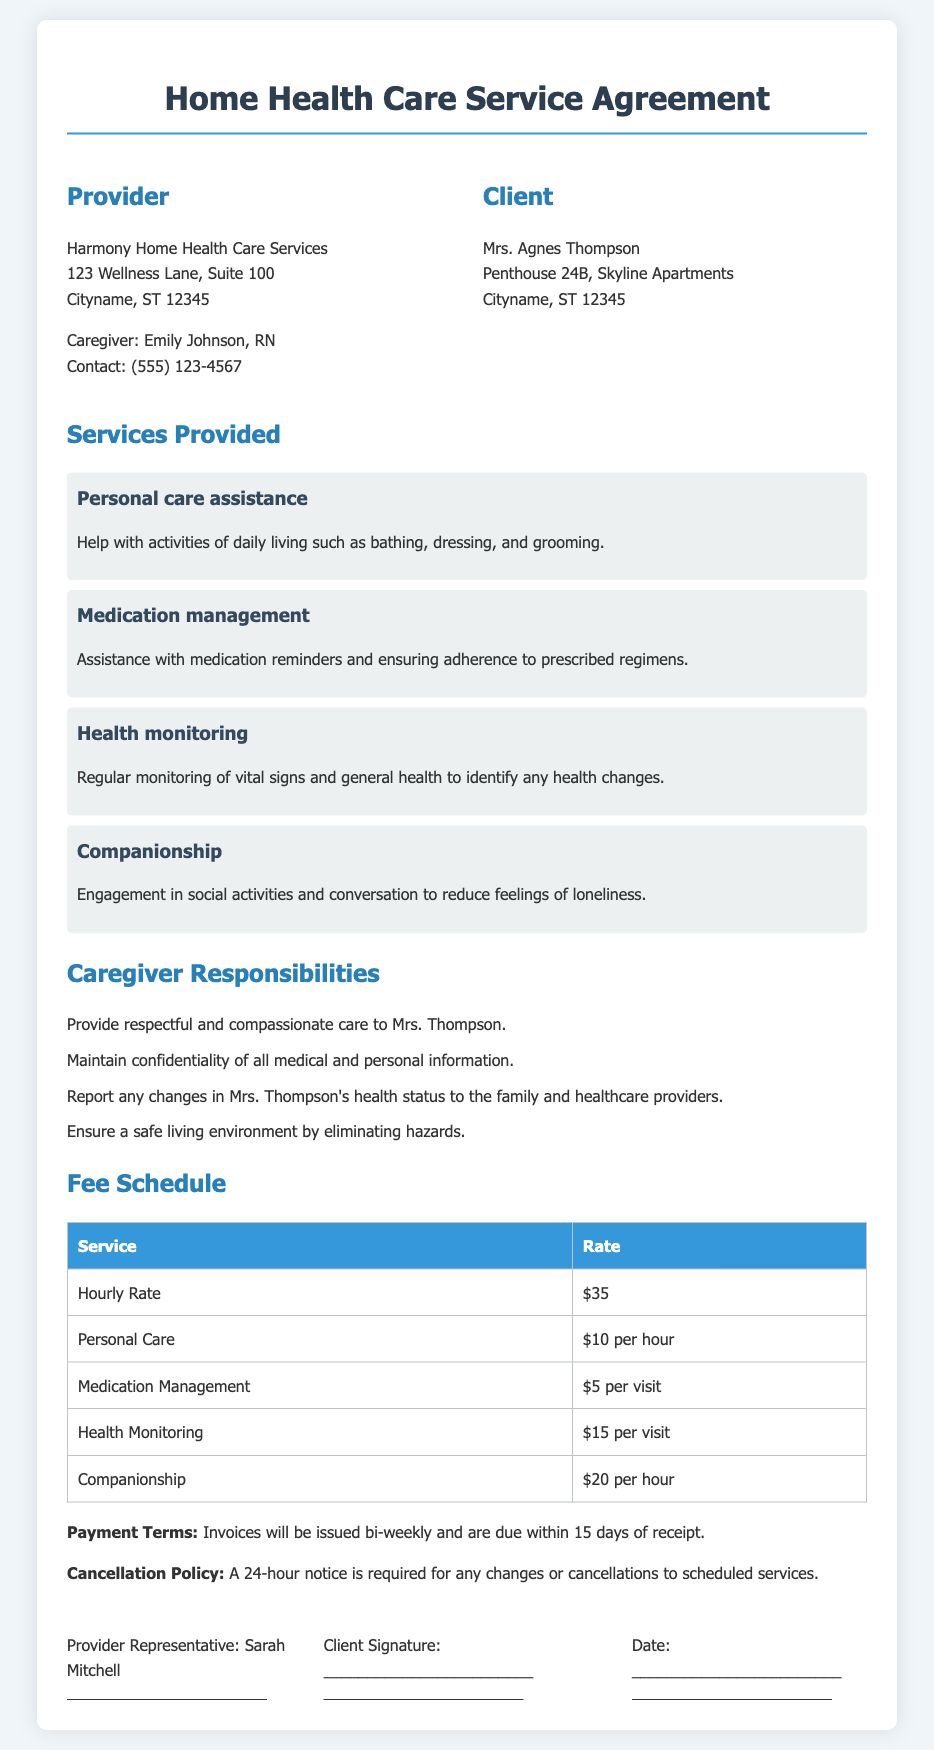what is the name of the provider? The provider is Harmony Home Health Care Services, as indicated at the beginning of the document.
Answer: Harmony Home Health Care Services who is the caregiver? The caregiver's name is mentioned as Emily Johnson, RN, in the provider section.
Answer: Emily Johnson, RN what is the hourly rate for services? The document outlines the hourly rate for services, which is listed in the fee schedule section.
Answer: $35 how much does companionship cost per hour? The cost for companionship services is specifically highlighted in the fee schedule.
Answer: $20 per hour what is required for cancellation of services? The document states the need for notice regarding cancellations in the fee schedule section.
Answer: 24-hour notice what should the caregiver report to the family? The responsibilities of the caregiver include a specific duty towards the family, as outlined in the responsibilities section.
Answer: Changes in Mrs. Thompson's health status who must sign the agreement? The signatures section indicates who needs to sign the agreement.
Answer: Provider Representative and Client how often will invoices be issued? The payment terms in the document specify the frequency of invoice issuance.
Answer: Bi-weekly 